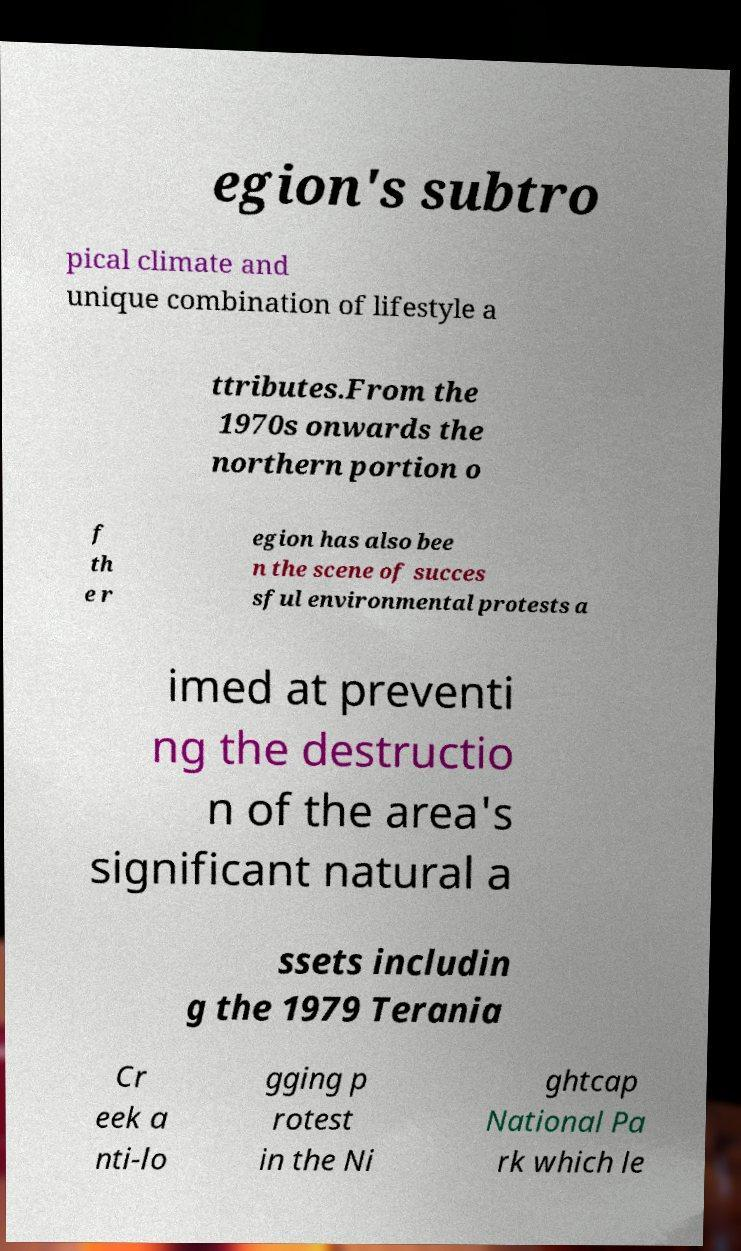There's text embedded in this image that I need extracted. Can you transcribe it verbatim? egion's subtro pical climate and unique combination of lifestyle a ttributes.From the 1970s onwards the northern portion o f th e r egion has also bee n the scene of succes sful environmental protests a imed at preventi ng the destructio n of the area's significant natural a ssets includin g the 1979 Terania Cr eek a nti-lo gging p rotest in the Ni ghtcap National Pa rk which le 